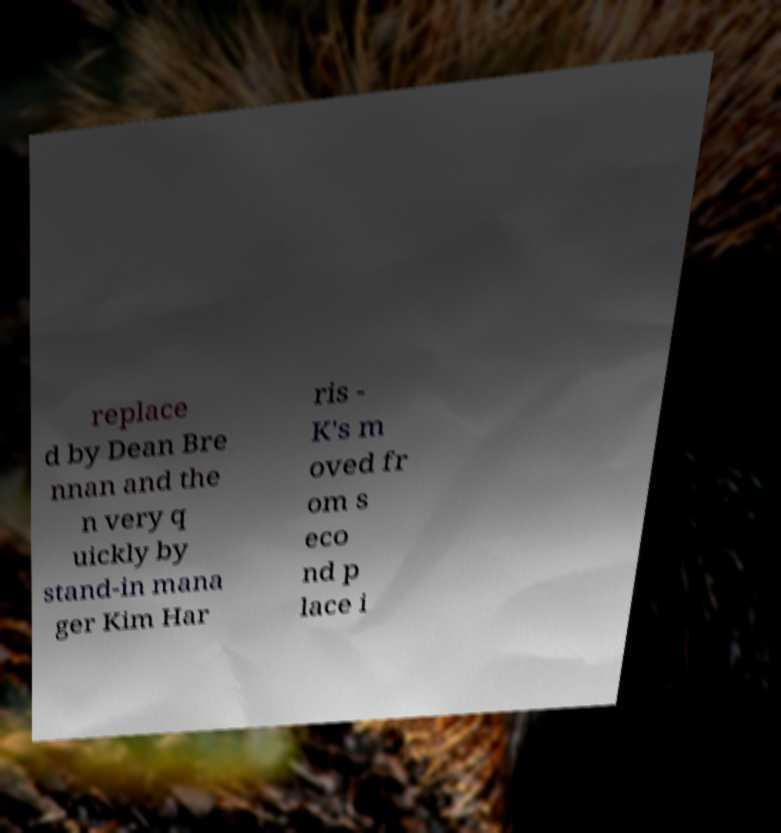What messages or text are displayed in this image? I need them in a readable, typed format. replace d by Dean Bre nnan and the n very q uickly by stand-in mana ger Kim Har ris - K's m oved fr om s eco nd p lace i 